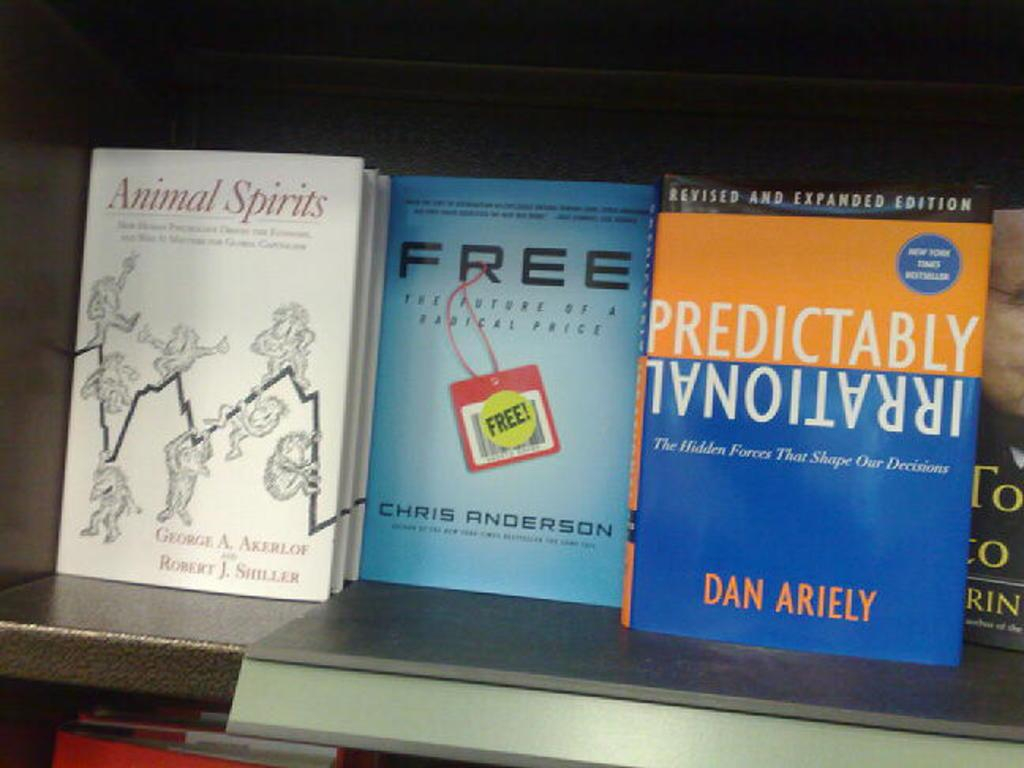<image>
Give a short and clear explanation of the subsequent image. Books on a shelf which one of the titles is Animal Spirits. 